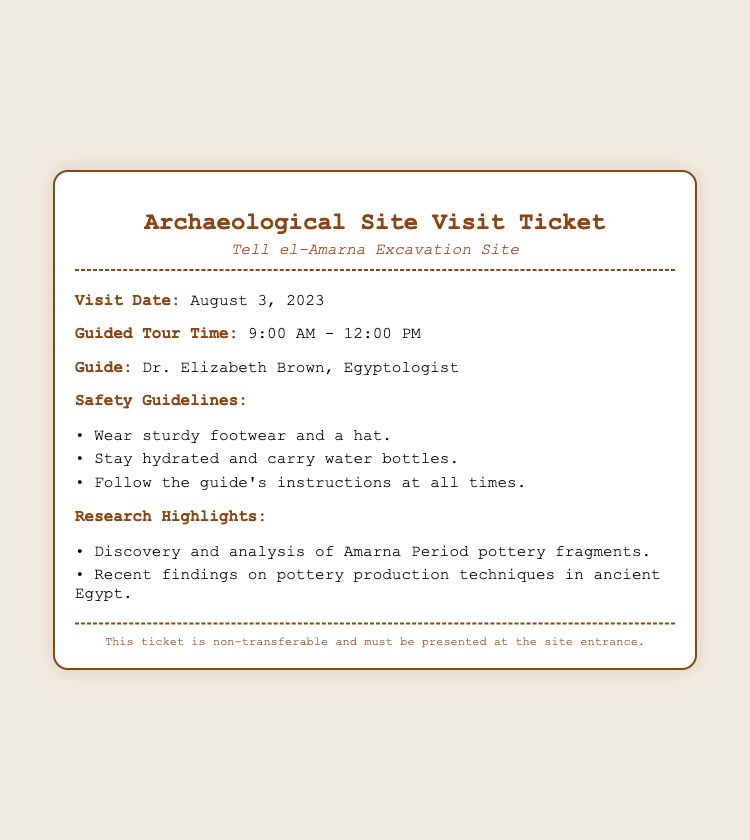What is the visit date? The visit date is clearly stated in the document under the "Visit Date" label.
Answer: August 3, 2023 Who is the guide for the tour? The guide's name is provided in the "Guide" section of the document.
Answer: Dr. Elizabeth Brown What are the guided tour hours? The tour hours are specified in the "Guided Tour Time" section.
Answer: 9:00 AM - 12:00 PM What safety guideline mentions clothing? The guidelines detail what visitors should wear for safety.
Answer: Wear sturdy footwear and a hat What is one of the research highlights? The "Research Highlights" section lists important findings relevant to the excavation.
Answer: Discovery and analysis of Amarna Period pottery fragments Why is it important to stay hydrated? Staying hydrated is emphasized for safety and comfort during the visit.
Answer: Safety guideline What type of ticket is this document? The document specifies its type in the title at the top.
Answer: Archaeological Site Visit Ticket Which excavation site does this ticket pertain to? The excavation site is mentioned in the subtitle of the ticket.
Answer: Tell el-Amarna 